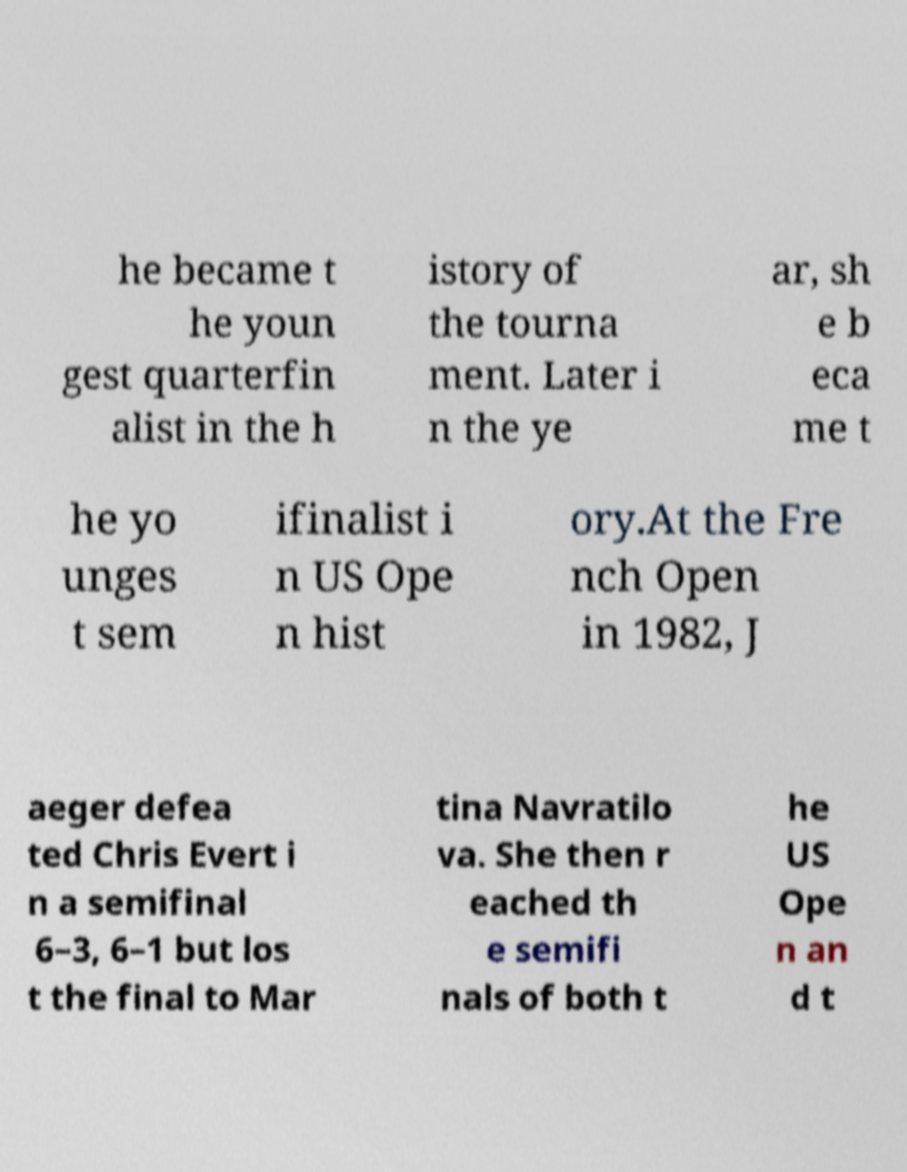Can you accurately transcribe the text from the provided image for me? he became t he youn gest quarterfin alist in the h istory of the tourna ment. Later i n the ye ar, sh e b eca me t he yo unges t sem ifinalist i n US Ope n hist ory.At the Fre nch Open in 1982, J aeger defea ted Chris Evert i n a semifinal 6–3, 6–1 but los t the final to Mar tina Navratilo va. She then r eached th e semifi nals of both t he US Ope n an d t 